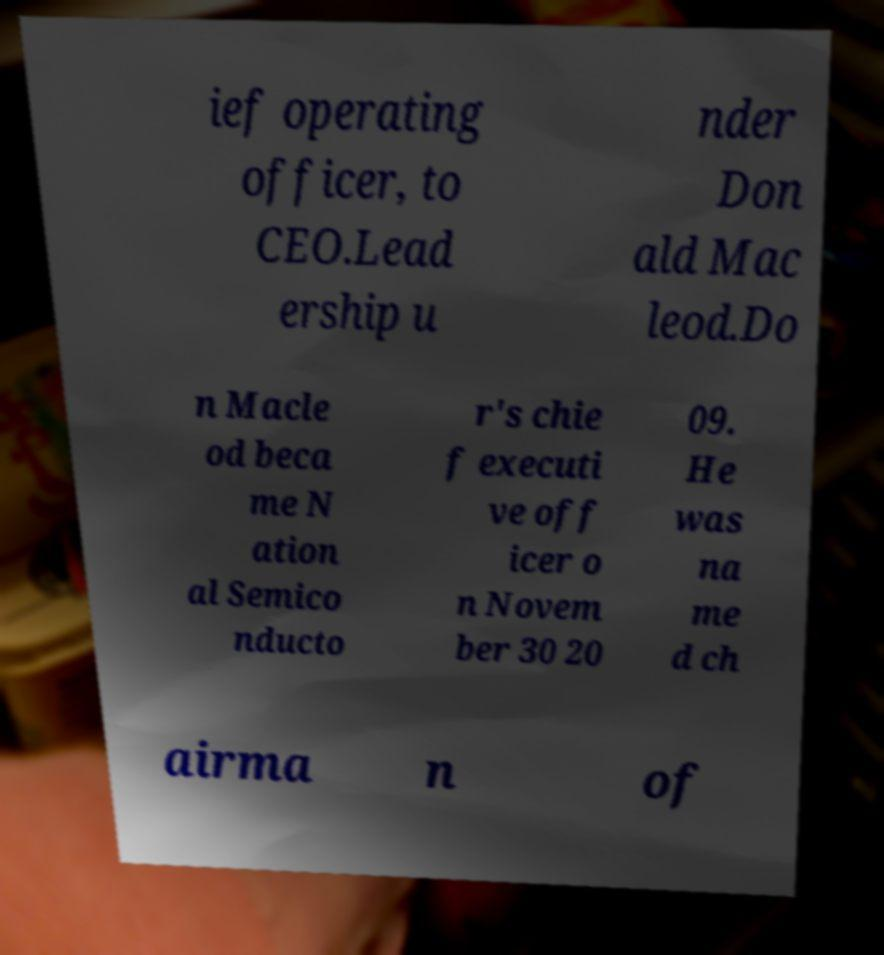Please identify and transcribe the text found in this image. ief operating officer, to CEO.Lead ership u nder Don ald Mac leod.Do n Macle od beca me N ation al Semico nducto r's chie f executi ve off icer o n Novem ber 30 20 09. He was na me d ch airma n of 